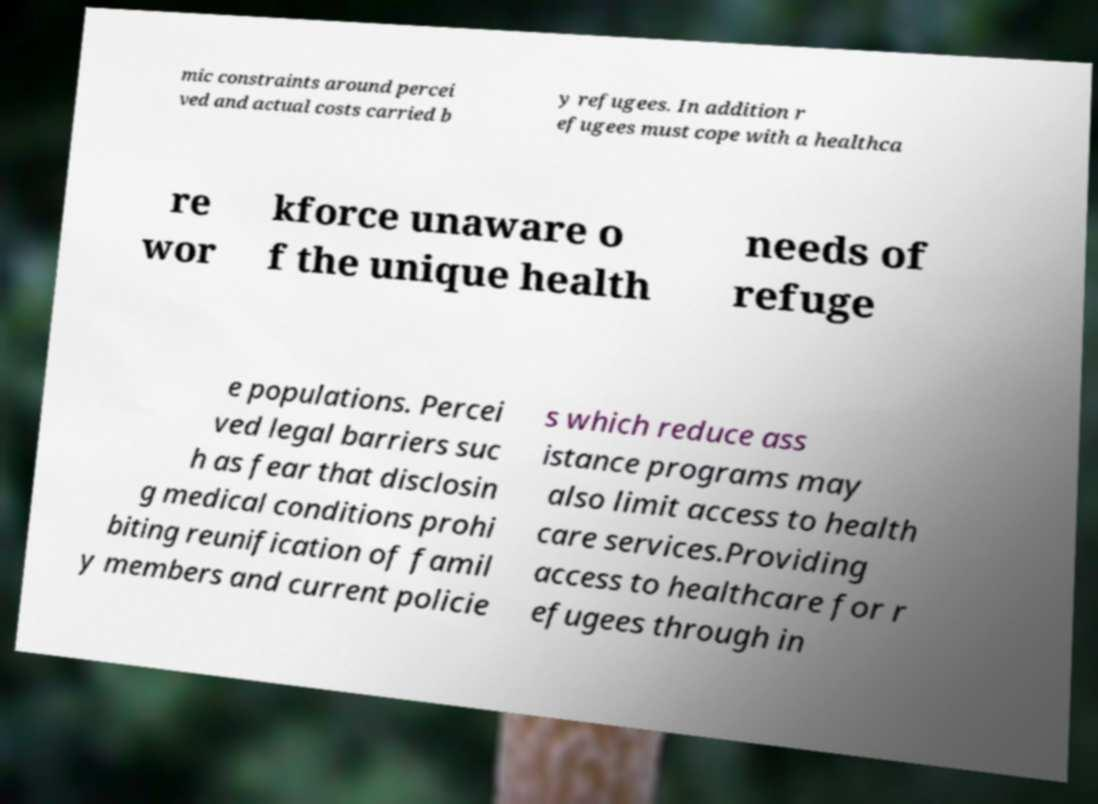I need the written content from this picture converted into text. Can you do that? mic constraints around percei ved and actual costs carried b y refugees. In addition r efugees must cope with a healthca re wor kforce unaware o f the unique health needs of refuge e populations. Percei ved legal barriers suc h as fear that disclosin g medical conditions prohi biting reunification of famil y members and current policie s which reduce ass istance programs may also limit access to health care services.Providing access to healthcare for r efugees through in 